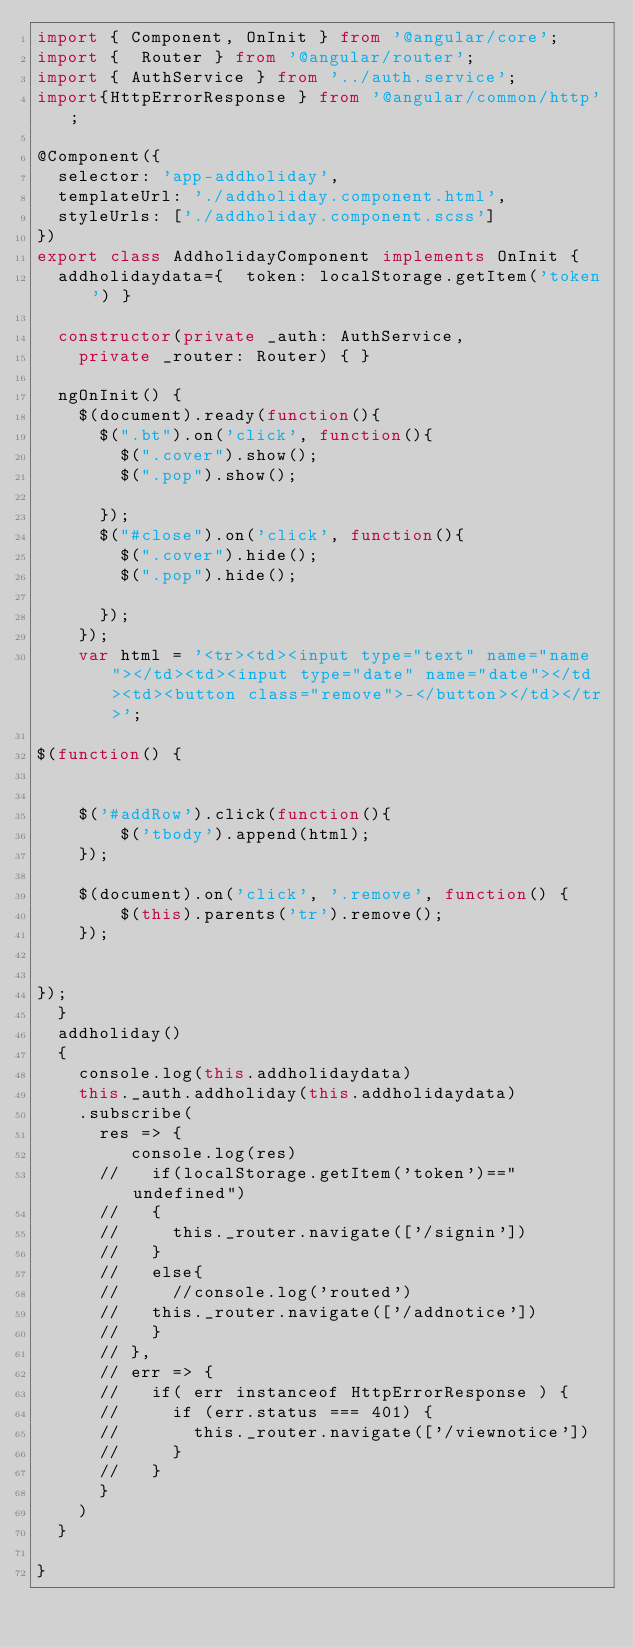Convert code to text. <code><loc_0><loc_0><loc_500><loc_500><_TypeScript_>import { Component, OnInit } from '@angular/core';
import {  Router } from '@angular/router';
import { AuthService } from '../auth.service';
import{HttpErrorResponse } from '@angular/common/http';

@Component({
  selector: 'app-addholiday',
  templateUrl: './addholiday.component.html',
  styleUrls: ['./addholiday.component.scss']
})
export class AddholidayComponent implements OnInit {
  addholidaydata={  token: localStorage.getItem('token') }

  constructor(private _auth: AuthService,
    private _router: Router) { }

  ngOnInit() {
    $(document).ready(function(){
      $(".bt").on('click', function(){
        $(".cover").show();
        $(".pop").show();
        
      });
      $("#close").on('click', function(){
        $(".cover").hide();
        $(".pop").hide();
        
      });
    });
    var html = '<tr><td><input type="text" name="name"></td><td><input type="date" name="date"></td><td><button class="remove">-</button></td></tr>';
 
$(function() {
   
 
    $('#addRow').click(function(){
        $('tbody').append(html);
    });
 
    $(document).on('click', '.remove', function() {
        $(this).parents('tr').remove();
    });
 
   
});
  }
  addholiday()
  {
    console.log(this.addholidaydata)
    this._auth.addholiday(this.addholidaydata)
    .subscribe(
      res => {
         console.log(res)
      //   if(localStorage.getItem('token')=="undefined")
      //   {
      //     this._router.navigate(['/signin'])
      //   }
      //   else{
      //     //console.log('routed')
      //   this._router.navigate(['/addnotice'])
      //   }
      // },
      // err => {
      //   if( err instanceof HttpErrorResponse ) {
      //     if (err.status === 401) {
      //       this._router.navigate(['/viewnotice'])
      //     }
      //   }
      }
    )
  }

}
</code> 